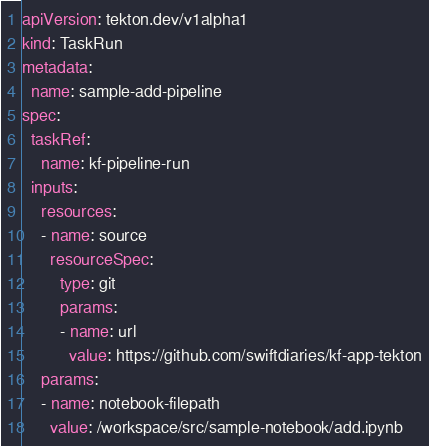Convert code to text. <code><loc_0><loc_0><loc_500><loc_500><_YAML_>apiVersion: tekton.dev/v1alpha1
kind: TaskRun
metadata:
  name: sample-add-pipeline
spec:
  taskRef:
    name: kf-pipeline-run
  inputs:
    resources:
    - name: source
      resourceSpec:
        type: git
        params:
        - name: url
          value: https://github.com/swiftdiaries/kf-app-tekton
    params:
    - name: notebook-filepath
      value: /workspace/src/sample-notebook/add.ipynb
</code> 